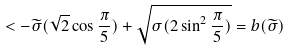Convert formula to latex. <formula><loc_0><loc_0><loc_500><loc_500>< - \widetilde { \sigma } ( \sqrt { 2 } \cos { \frac { \pi } { 5 } } ) + \sqrt { \sigma ( 2 \sin ^ { 2 } { \frac { \pi } { 5 } } ) } = b ( \widetilde { \sigma } )</formula> 